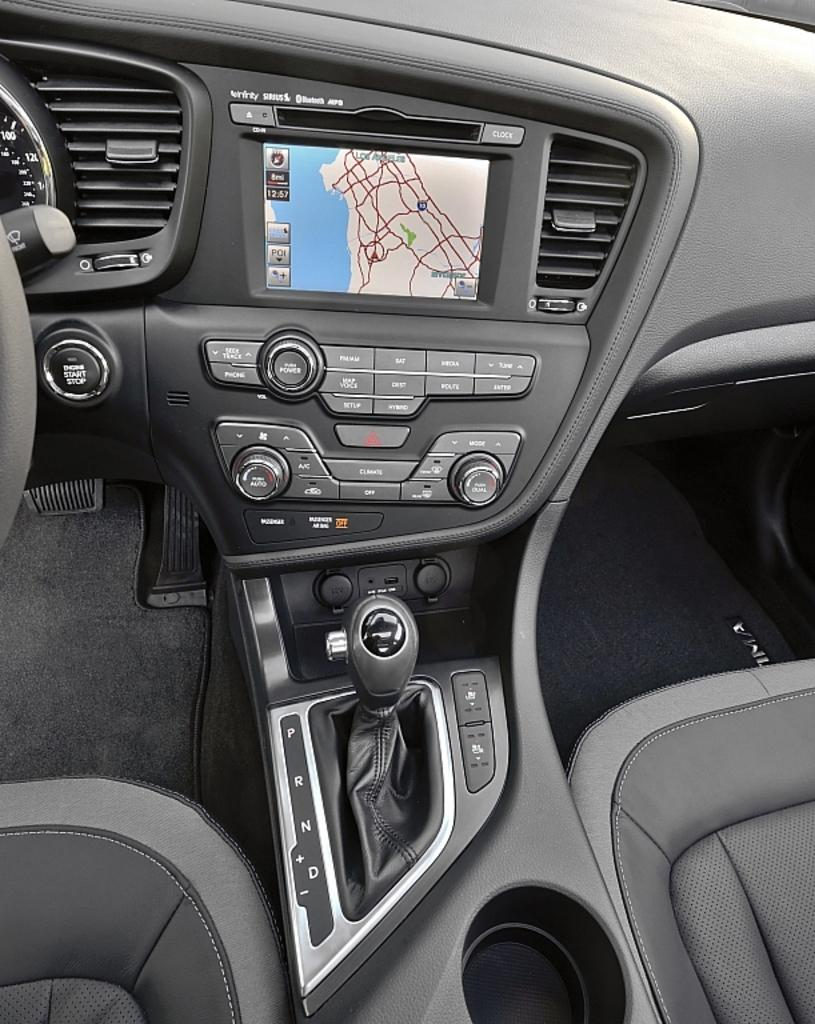What type of control is used to change gears in the car? There is a gear lever in the car. What device is present for displaying information or entertainment in the car? There is a screen in the car. What feature is available for regulating the temperature and airflow in the car? There are air conditioners in the car. How many seats are present in the car? There are seats in the car. What type of bread is being served in the car? There is no bread present in the car; the facts mention buttons, gear lever, screen, air conditioners, and seats. Can you see any goldfish swimming in the car? There are no goldfish present in the car; the facts mention buttons, gear lever, screen, air conditioners, and seats. 